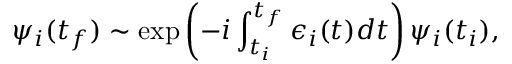Convert formula to latex. <formula><loc_0><loc_0><loc_500><loc_500>\psi _ { i } ( t _ { f } ) \sim \exp \left ( - i \int _ { t _ { i } } ^ { t _ { f } } \epsilon _ { i } ( t ) d t \right ) \psi _ { i } ( t _ { i } ) ,</formula> 